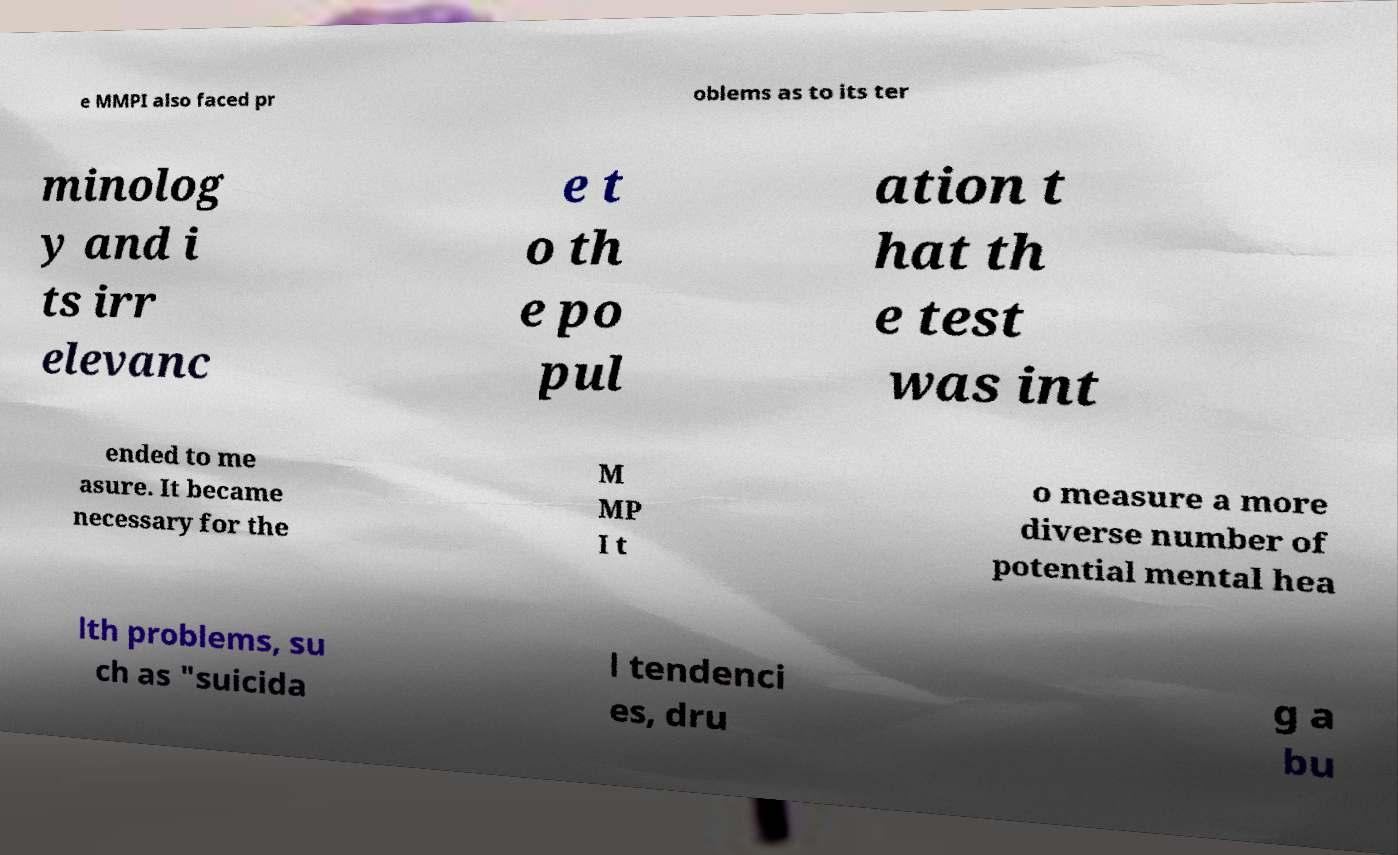What messages or text are displayed in this image? I need them in a readable, typed format. e MMPI also faced pr oblems as to its ter minolog y and i ts irr elevanc e t o th e po pul ation t hat th e test was int ended to me asure. It became necessary for the M MP I t o measure a more diverse number of potential mental hea lth problems, su ch as "suicida l tendenci es, dru g a bu 